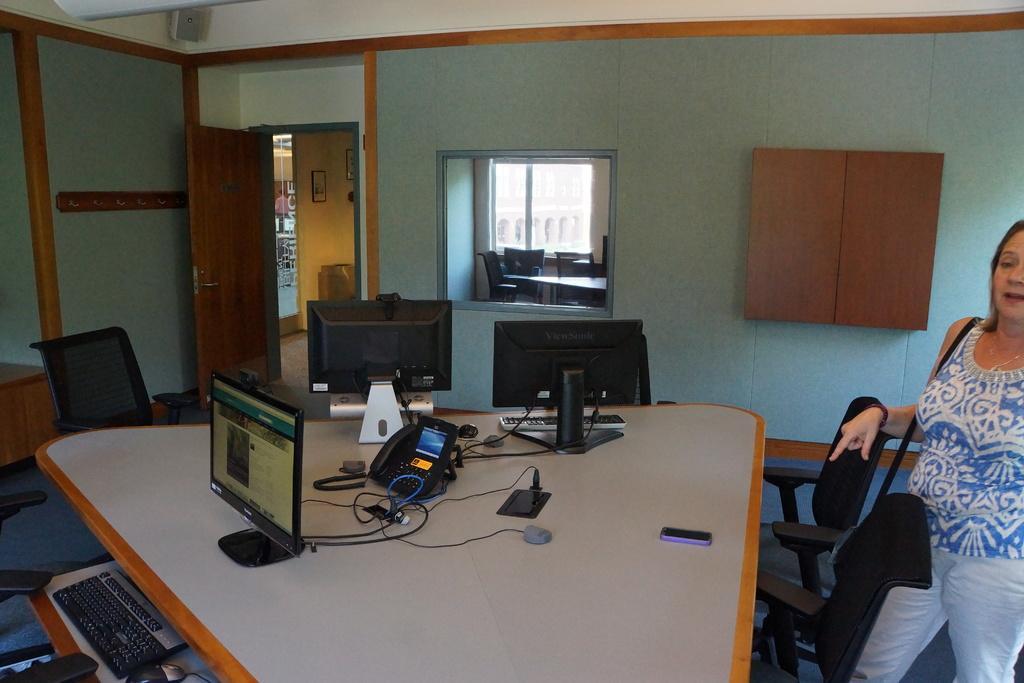Can you describe this image briefly? In the image we can see a woman standing. There are many chairs and a table. There are three systems on the table. This is a telephone and a window. 